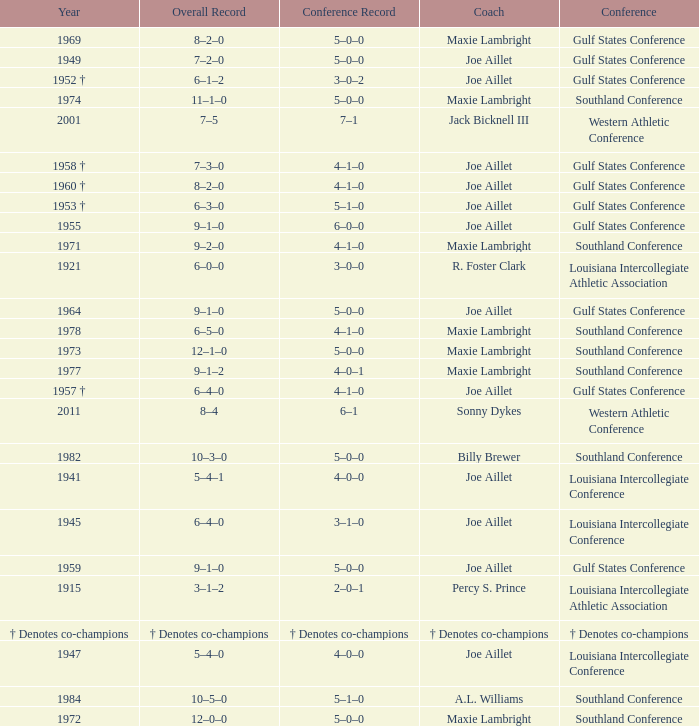What is the conference record for the year of 1971? 4–1–0. 